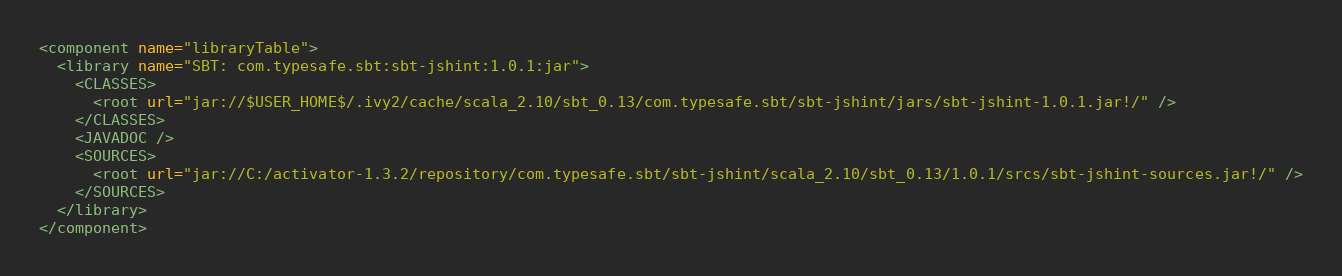Convert code to text. <code><loc_0><loc_0><loc_500><loc_500><_XML_><component name="libraryTable">
  <library name="SBT: com.typesafe.sbt:sbt-jshint:1.0.1:jar">
    <CLASSES>
      <root url="jar://$USER_HOME$/.ivy2/cache/scala_2.10/sbt_0.13/com.typesafe.sbt/sbt-jshint/jars/sbt-jshint-1.0.1.jar!/" />
    </CLASSES>
    <JAVADOC />
    <SOURCES>
      <root url="jar://C:/activator-1.3.2/repository/com.typesafe.sbt/sbt-jshint/scala_2.10/sbt_0.13/1.0.1/srcs/sbt-jshint-sources.jar!/" />
    </SOURCES>
  </library>
</component></code> 